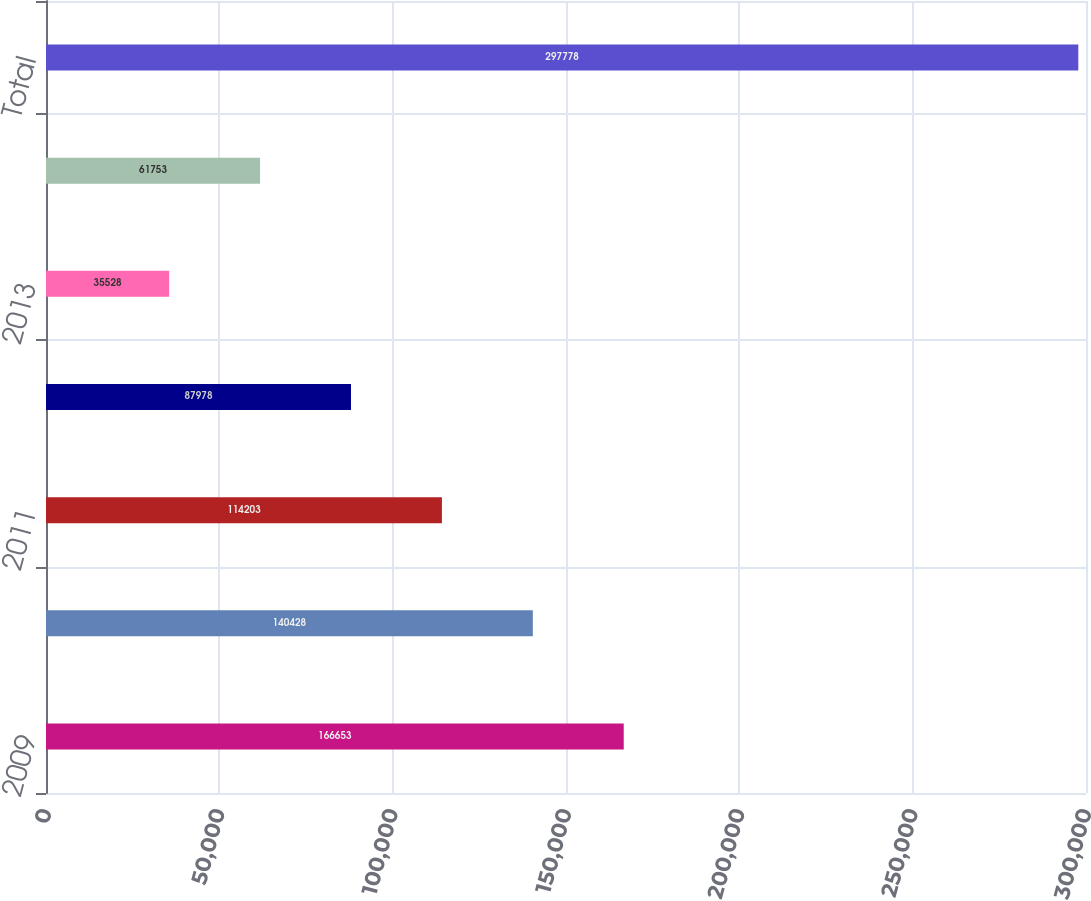Convert chart. <chart><loc_0><loc_0><loc_500><loc_500><bar_chart><fcel>2009<fcel>2010<fcel>2011<fcel>2012<fcel>2013<fcel>Thereafter<fcel>Total<nl><fcel>166653<fcel>140428<fcel>114203<fcel>87978<fcel>35528<fcel>61753<fcel>297778<nl></chart> 